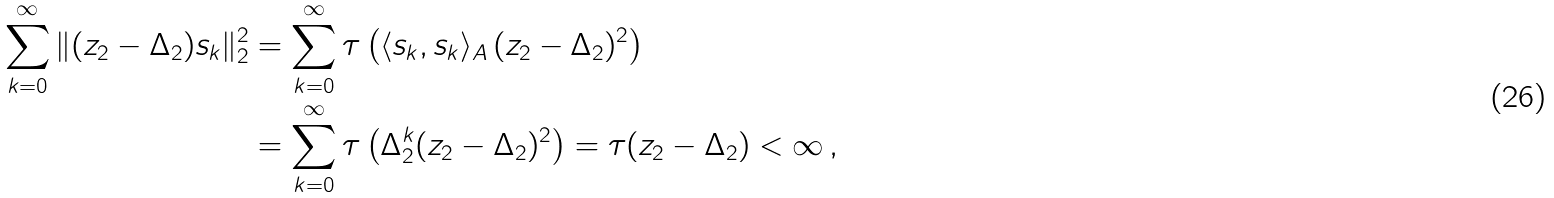<formula> <loc_0><loc_0><loc_500><loc_500>\sum _ { k = 0 } ^ { \infty } \| ( z _ { 2 } - \Delta _ { 2 } ) s _ { k } \| _ { 2 } ^ { 2 } & = \sum _ { k = 0 } ^ { \infty } \tau \left ( \langle s _ { k } , s _ { k } \rangle _ { A } \, ( z _ { 2 } - \Delta _ { 2 } ) ^ { 2 } \right ) \\ & = \sum _ { k = 0 } ^ { \infty } \tau \left ( \Delta _ { 2 } ^ { k } ( z _ { 2 } - \Delta _ { 2 } ) ^ { 2 } \right ) = \tau ( z _ { 2 } - \Delta _ { 2 } ) < \infty \, ,</formula> 